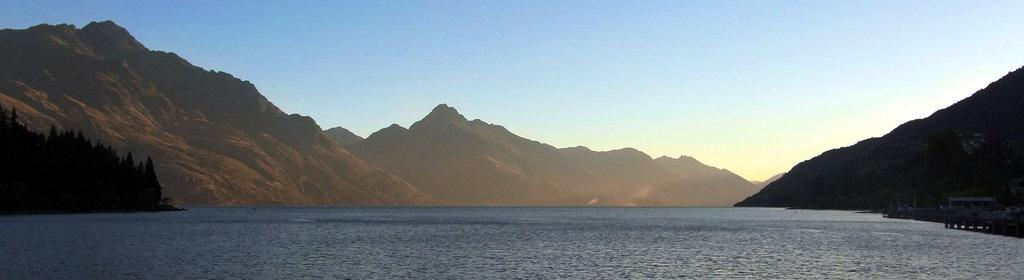What type of natural feature is depicted in the image? There is a sea in the image. What geographical features surround the sea? There are mountains around the sea. Can you describe any man-made structures near the sea? There is a small bridge beside the sea on the right side. What type of seed is growing on the mountains in the image? There is no seed growing on the mountains in the image; the mountains are depicted as a geographical feature. 